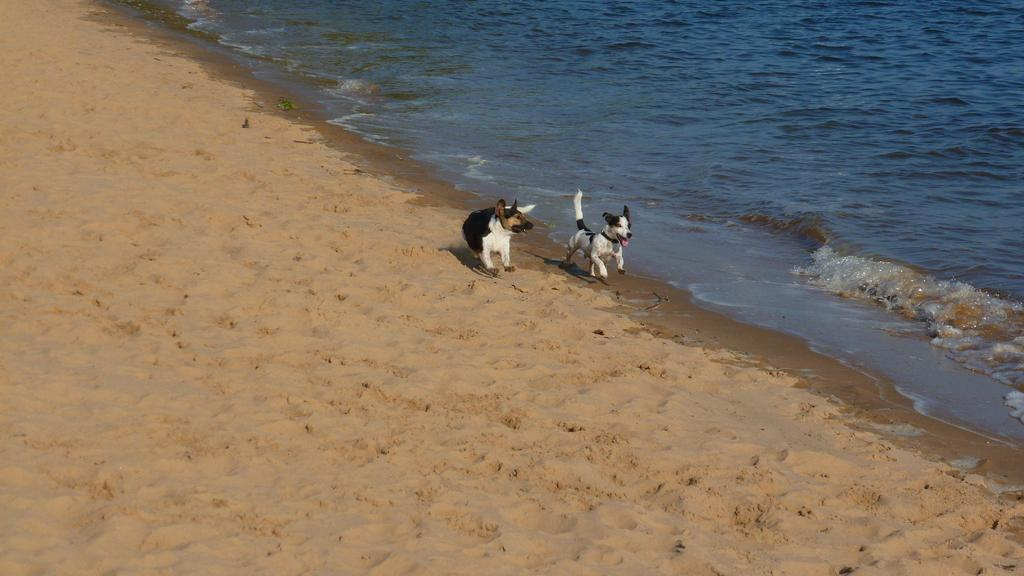How many dogs are present in the image? There are two dogs in the image. What color are the dogs in the image? The dogs are in black and white color. What can be seen in the background of the image? There is water and sand visible in the background of the image. What type of sail can be seen in the image? There is no sail present in the image. What direction is the zephyr blowing in the image? There is no mention of a zephyr or wind in the image, so it cannot be determined. 